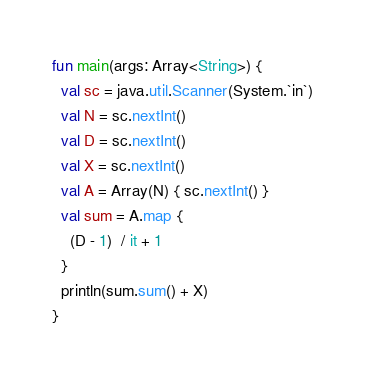Convert code to text. <code><loc_0><loc_0><loc_500><loc_500><_Kotlin_>fun main(args: Array<String>) {
  val sc = java.util.Scanner(System.`in`)
  val N = sc.nextInt()
  val D = sc.nextInt()
  val X = sc.nextInt()
  val A = Array(N) { sc.nextInt() }
  val sum = A.map {
    (D - 1)  / it + 1
  }
  println(sum.sum() + X)
}
</code> 